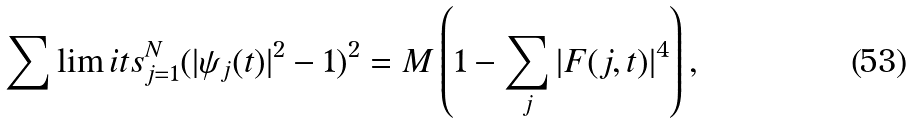<formula> <loc_0><loc_0><loc_500><loc_500>\sum \lim i t s _ { j = 1 } ^ { N } ( | \psi _ { j } ( t ) | ^ { 2 } - 1 ) ^ { 2 } = M \left ( 1 - \sum _ { j } | F ( j , t ) | ^ { 4 } \right ) ,</formula> 